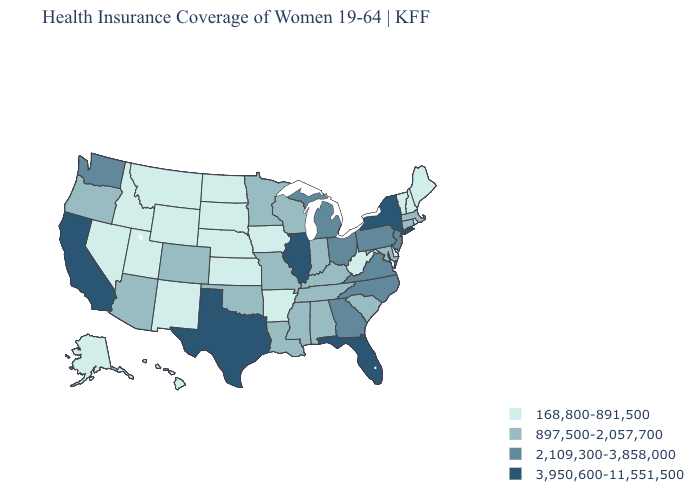Does Oregon have the highest value in the West?
Keep it brief. No. Does Vermont have the lowest value in the Northeast?
Be succinct. Yes. Name the states that have a value in the range 168,800-891,500?
Write a very short answer. Alaska, Arkansas, Delaware, Hawaii, Idaho, Iowa, Kansas, Maine, Montana, Nebraska, Nevada, New Hampshire, New Mexico, North Dakota, Rhode Island, South Dakota, Utah, Vermont, West Virginia, Wyoming. Among the states that border Washington , does Oregon have the lowest value?
Write a very short answer. No. Does California have the highest value in the USA?
Short answer required. Yes. What is the highest value in the West ?
Short answer required. 3,950,600-11,551,500. What is the highest value in the South ?
Give a very brief answer. 3,950,600-11,551,500. Name the states that have a value in the range 168,800-891,500?
Keep it brief. Alaska, Arkansas, Delaware, Hawaii, Idaho, Iowa, Kansas, Maine, Montana, Nebraska, Nevada, New Hampshire, New Mexico, North Dakota, Rhode Island, South Dakota, Utah, Vermont, West Virginia, Wyoming. Name the states that have a value in the range 3,950,600-11,551,500?
Give a very brief answer. California, Florida, Illinois, New York, Texas. What is the value of Nebraska?
Answer briefly. 168,800-891,500. Name the states that have a value in the range 897,500-2,057,700?
Give a very brief answer. Alabama, Arizona, Colorado, Connecticut, Indiana, Kentucky, Louisiana, Maryland, Massachusetts, Minnesota, Mississippi, Missouri, Oklahoma, Oregon, South Carolina, Tennessee, Wisconsin. What is the lowest value in the USA?
Concise answer only. 168,800-891,500. Name the states that have a value in the range 897,500-2,057,700?
Short answer required. Alabama, Arizona, Colorado, Connecticut, Indiana, Kentucky, Louisiana, Maryland, Massachusetts, Minnesota, Mississippi, Missouri, Oklahoma, Oregon, South Carolina, Tennessee, Wisconsin. Does Arizona have the highest value in the West?
Quick response, please. No. 